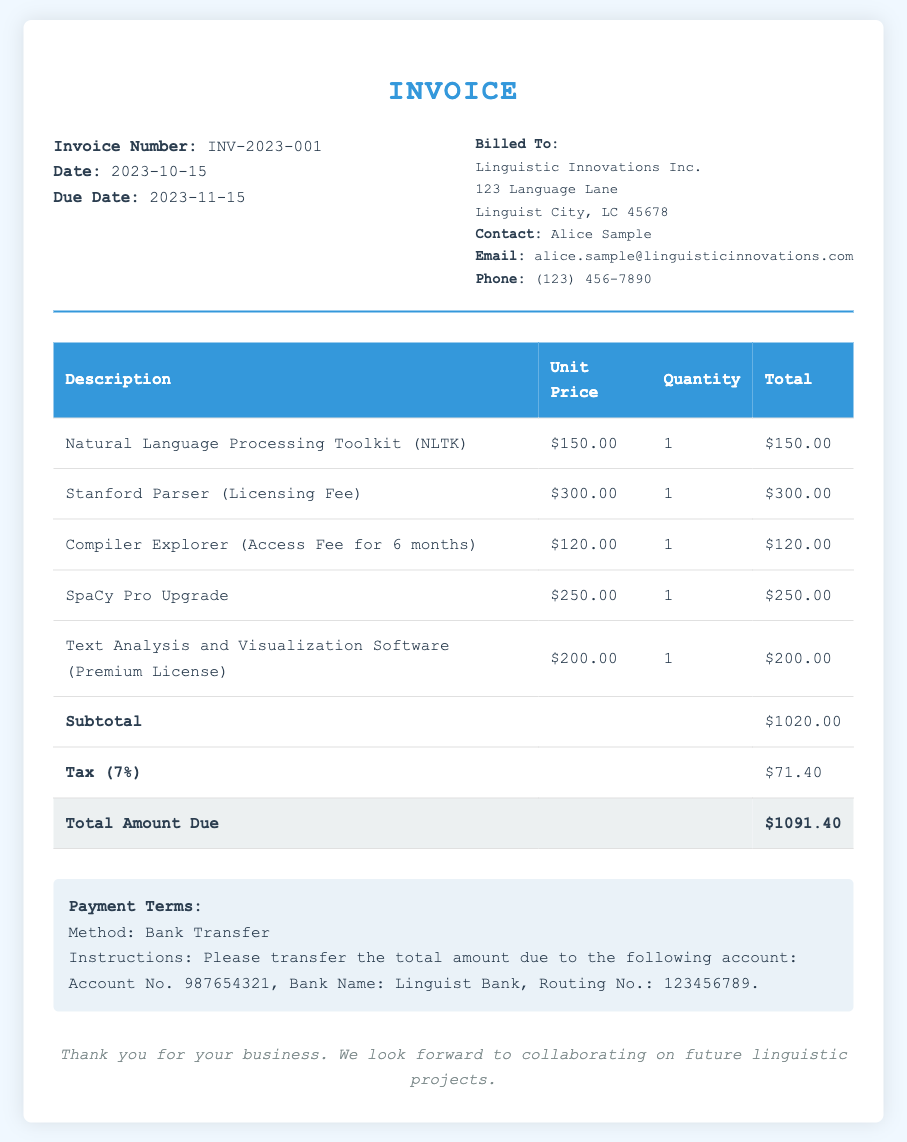What is the invoice number? The invoice number is specified at the top of the document under "Invoice Number."
Answer: INV-2023-001 What is the due date of the invoice? The due date is stated in the header section of the document.
Answer: 2023-11-15 How much is the tax applied to the invoice? The tax amount is detailed in the invoice summary table.
Answer: $71.40 What is the payment method indicated in the document? The payment method is mentioned in the payment terms section.
Answer: Bank Transfer How much was charged for the Stanford Parser licensing fee? The amount charged for the Stanford Parser is shown in the itemized table.
Answer: $300.00 What is the total amount due? The total amount due is listed in the summary section at the bottom of the invoice.
Answer: $1091.40 What is the quantity of the Natural Language Processing Toolkit purchased? The quantity of the item is found in the itemized charges table under the respective item.
Answer: 1 Who is the contact person for the billing information? The contact person is indicated in the billing information section of the document.
Answer: Alice Sample What is included in the description for the last item? The description for the last item can be found in the itemized charges table.
Answer: Text Analysis and Visualization Software (Premium License) 